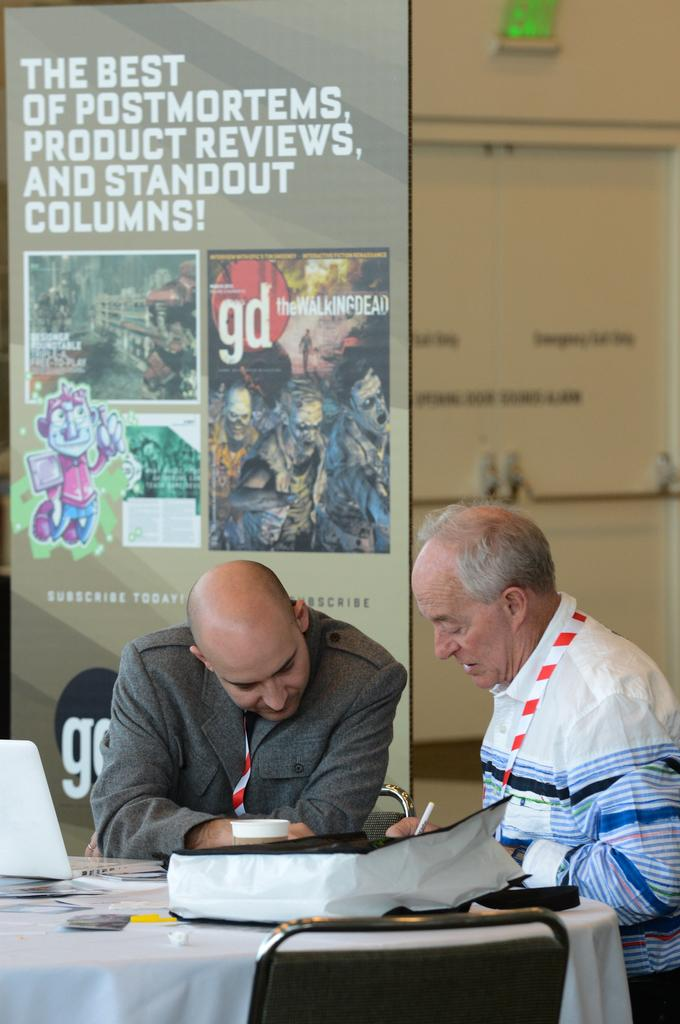<image>
Provide a brief description of the given image. Two men sitting at a table in front of a GD magazine banner. 